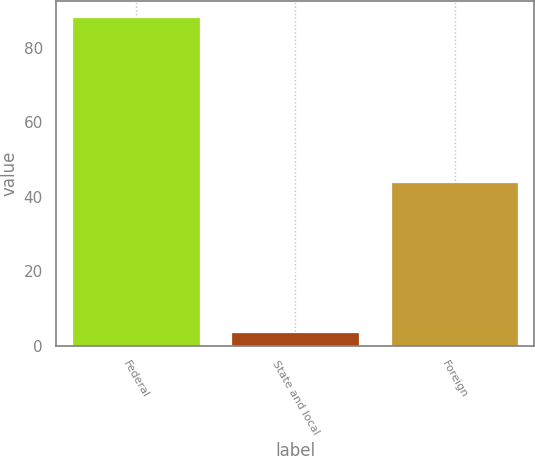Convert chart to OTSL. <chart><loc_0><loc_0><loc_500><loc_500><bar_chart><fcel>Federal<fcel>State and local<fcel>Foreign<nl><fcel>88.3<fcel>3.7<fcel>43.9<nl></chart> 